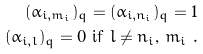<formula> <loc_0><loc_0><loc_500><loc_500>( \alpha _ { i , m _ { i } } ) _ { q } = ( \alpha _ { i , n _ { i } } ) _ { q } = 1 \\ ( \alpha _ { i , l } ) _ { q } = 0 \text { if $l \neq n_{i}$, $m_{i}$ } .</formula> 